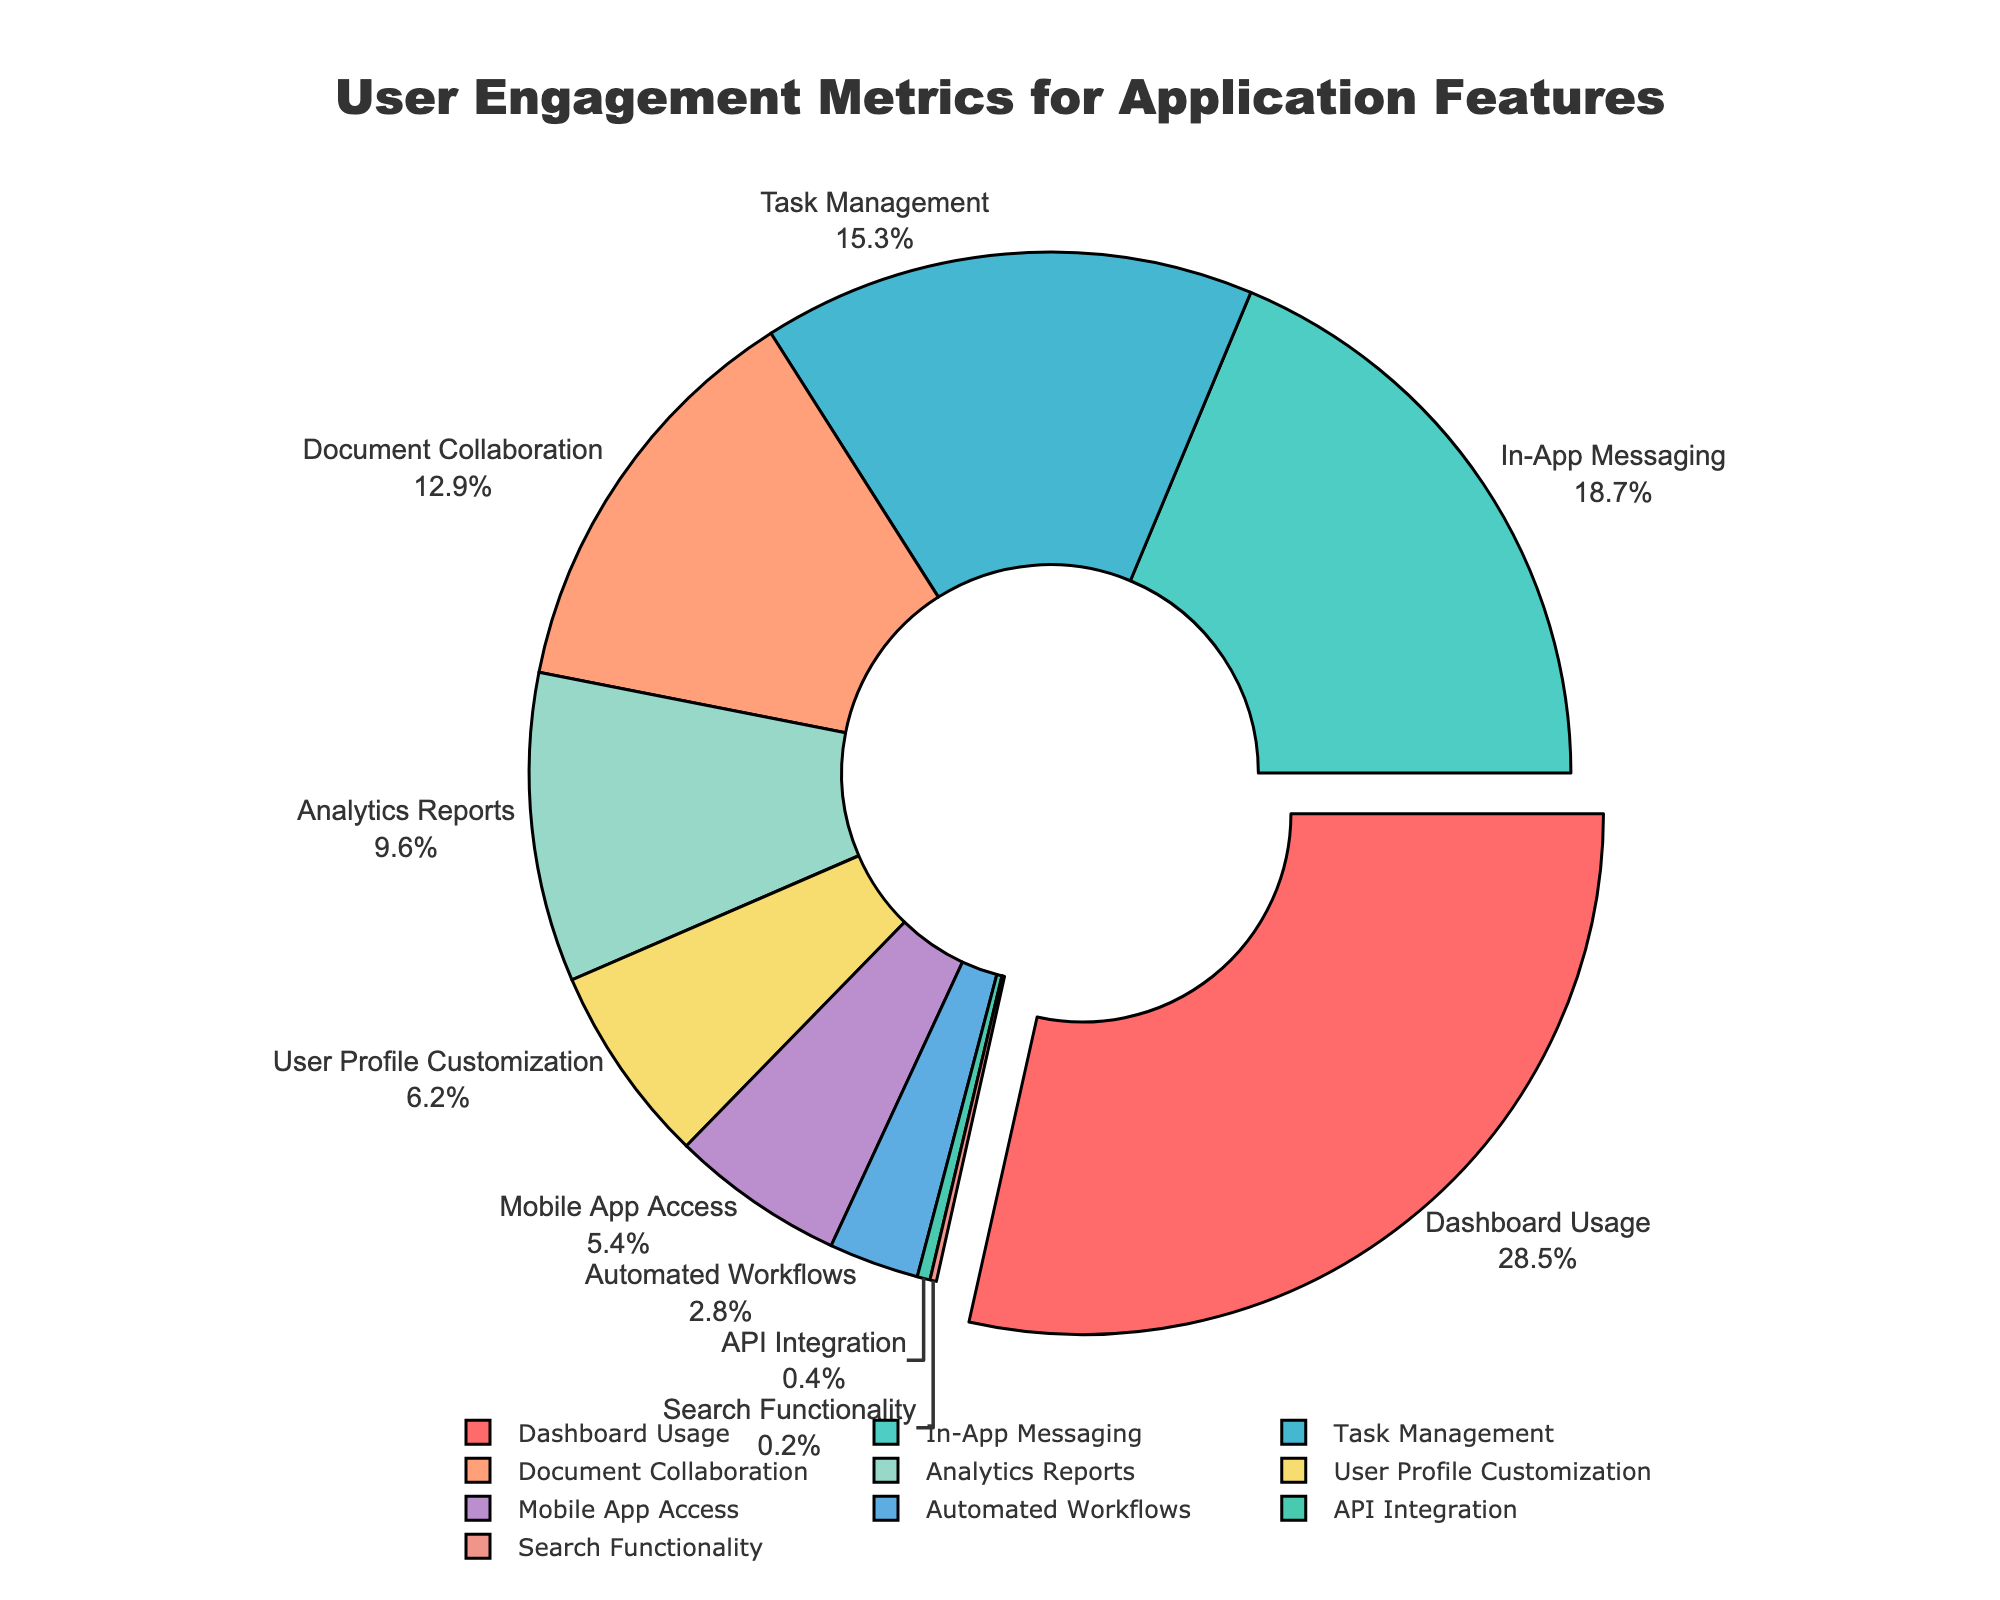Which feature has the highest engagement percentage? The slice with the largest area represents the feature that has the highest engagement percentage. In the chart, the feature "Dashboard Usage" occupies the largest slice with 28.5%.
Answer: Dashboard Usage Which feature has the lowest engagement percentage? The smallest slice represents the feature with the lowest engagement percentage. In the chart, "Search Functionality" occupies the smallest slice with 0.2%.
Answer: Search Functionality How much more engagement percentage does "In-App Messaging" have compared to "Task Management"? The engagement percentage for "In-App Messaging" is 18.7% and for "Task Management" it is 15.3%. The difference is calculated as 18.7 - 15.3, which equals 3.4%.
Answer: 3.4% What is the combined engagement percentage of "Document Collaboration" and "Analytics Reports"? The engagement percentage for "Document Collaboration" is 12.9% and for "Analytics Reports" it is 9.6%. The sum is 12.9 + 9.6, which equals 22.5%.
Answer: 22.5% Is "User Profile Customization" engagement percentage higher or lower than "Mobile App Access"? The engagement percentage for "User Profile Customization" is 6.2% and for "Mobile App Access" it is 5.4%. Since 6.2 is greater than 5.4, "User Profile Customization" is higher.
Answer: Higher Which features together make up more than 50% of the engagement? By adding the engagement percentages from highest to lowest, we observe that "Dashboard Usage" (28.5%), "In-App Messaging" (18.7%), and "Task Management" (15.3%) total to 62.5%, which is more than 50%.
Answer: Dashboard Usage, In-App Messaging, Task Management How does the engagement percentage of "Automated Workflows" compare to "API Integration"? The engagement percentage for "Automated Workflows" is 2.8% while "API Integration" is 0.4%. Since 2.8 is greater than 0.4, "Automated Workflows" has a higher engagement percentage.
Answer: Higher What is the average engagement percentage for the features "User Profile Customization", "Mobile App Access", and "Automated Workflows"? The engagement percentages for "User Profile Customization", "Mobile App Access", and "Automated Workflows" are 6.2%, 5.4%, and 2.8% respectively. The average is calculated as (6.2 + 5.4 + 2.8) / 3 = 4.8%.
Answer: 4.8% Identify the feature with a light blue-colored slice. The light blue-colored slice corresponds to "Document Collaboration" in the chart. It's visually represented with the color light blue and has an engagement percentage of 12.9%.
Answer: Document Collaboration 